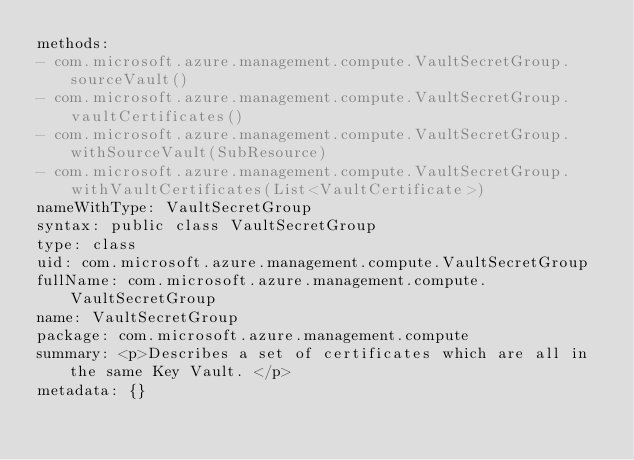<code> <loc_0><loc_0><loc_500><loc_500><_YAML_>methods:
- com.microsoft.azure.management.compute.VaultSecretGroup.sourceVault()
- com.microsoft.azure.management.compute.VaultSecretGroup.vaultCertificates()
- com.microsoft.azure.management.compute.VaultSecretGroup.withSourceVault(SubResource)
- com.microsoft.azure.management.compute.VaultSecretGroup.withVaultCertificates(List<VaultCertificate>)
nameWithType: VaultSecretGroup
syntax: public class VaultSecretGroup
type: class
uid: com.microsoft.azure.management.compute.VaultSecretGroup
fullName: com.microsoft.azure.management.compute.VaultSecretGroup
name: VaultSecretGroup
package: com.microsoft.azure.management.compute
summary: <p>Describes a set of certificates which are all in the same Key Vault. </p>
metadata: {}
</code> 